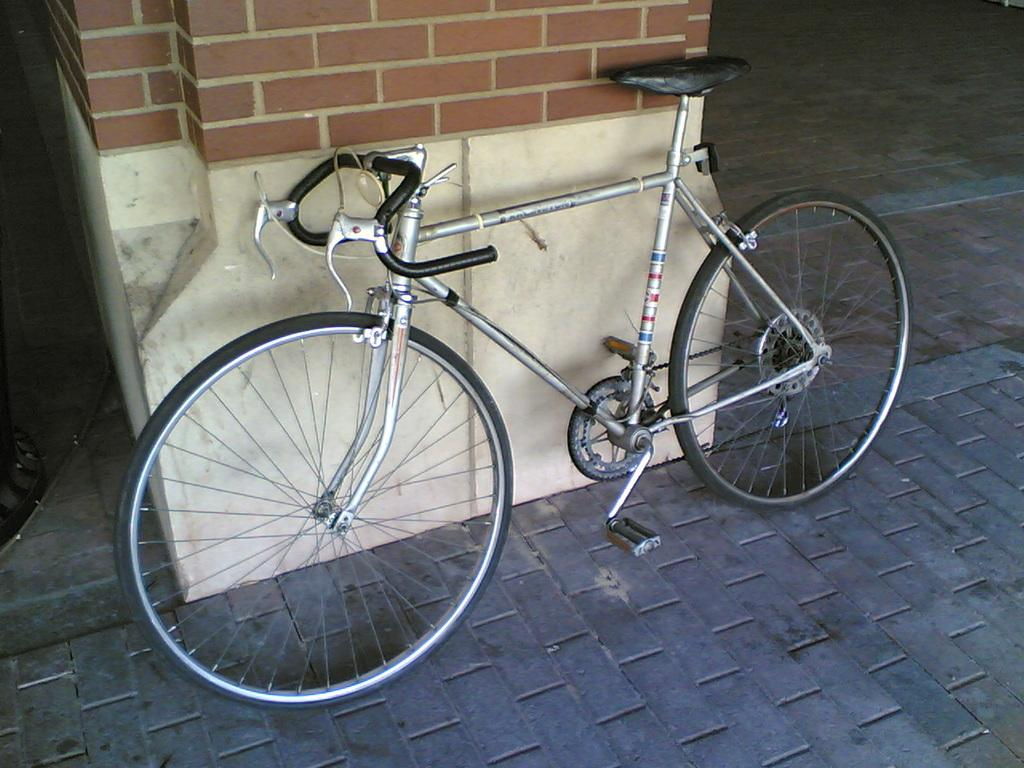What is the main object in the image? There is a bicycle in the image. How is the bicycle positioned in the image? The bicycle is placed on the ground. What can be seen in the background of the image? There is a wall in the background of the image. What type of disease is affecting the bicycle in the image? There is no disease affecting the bicycle in the image; it appears to be in good condition. 